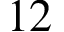<formula> <loc_0><loc_0><loc_500><loc_500>1 2</formula> 